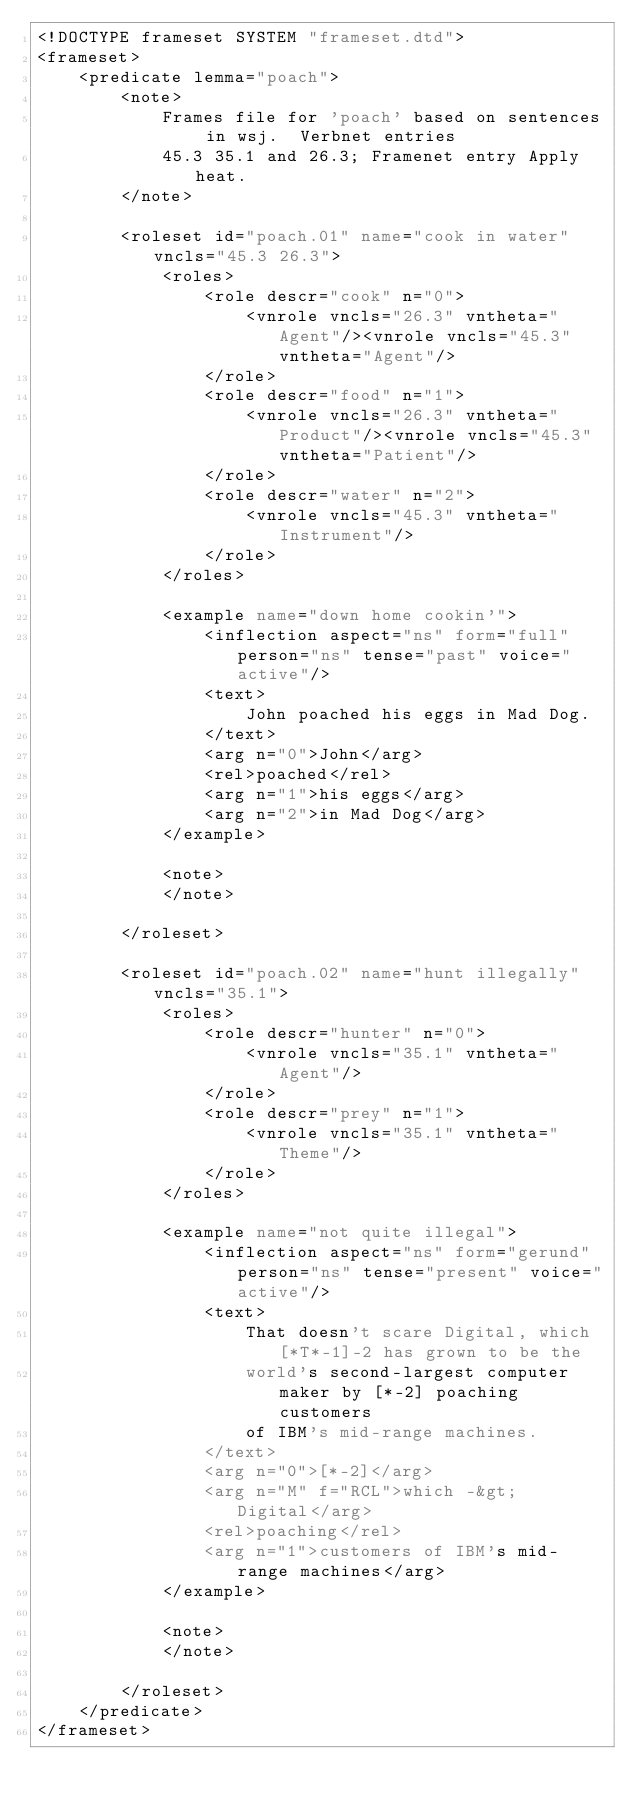<code> <loc_0><loc_0><loc_500><loc_500><_XML_><!DOCTYPE frameset SYSTEM "frameset.dtd">
<frameset>
    <predicate lemma="poach">
        <note>
            Frames file for 'poach' based on sentences in wsj.  Verbnet entries
            45.3 35.1 and 26.3; Framenet entry Apply heat.
        </note>
        
        <roleset id="poach.01" name="cook in water" vncls="45.3 26.3">
            <roles>
                <role descr="cook" n="0">
                    <vnrole vncls="26.3" vntheta="Agent"/><vnrole vncls="45.3" vntheta="Agent"/>
                </role>
                <role descr="food" n="1">
                    <vnrole vncls="26.3" vntheta="Product"/><vnrole vncls="45.3" vntheta="Patient"/>
                </role>
                <role descr="water" n="2">
                    <vnrole vncls="45.3" vntheta="Instrument"/>
                </role>
            </roles>
            
            <example name="down home cookin'">
                <inflection aspect="ns" form="full" person="ns" tense="past" voice="active"/>
                <text>
                    John poached his eggs in Mad Dog.
                </text>
                <arg n="0">John</arg>
                <rel>poached</rel>
                <arg n="1">his eggs</arg>
                <arg n="2">in Mad Dog</arg>
            </example>
            
            <note>
            </note>
            
        </roleset>
        
        <roleset id="poach.02" name="hunt illegally" vncls="35.1">
            <roles>
                <role descr="hunter" n="0">
                    <vnrole vncls="35.1" vntheta="Agent"/>
                </role>
                <role descr="prey" n="1">
                    <vnrole vncls="35.1" vntheta="Theme"/>
                </role>
            </roles>
            
            <example name="not quite illegal">
                <inflection aspect="ns" form="gerund" person="ns" tense="present" voice="active"/>
                <text>
                    That doesn't scare Digital, which [*T*-1]-2 has grown to be the
                    world's second-largest computer maker by [*-2] poaching customers
                    of IBM's mid-range machines. 
                </text>
                <arg n="0">[*-2]</arg>
                <arg n="M" f="RCL">which -&gt;  Digital</arg>
                <rel>poaching</rel>
                <arg n="1">customers of IBM's mid-range machines</arg>
            </example>
            
            <note>
            </note>
            
        </roleset>
    </predicate>
</frameset>
</code> 